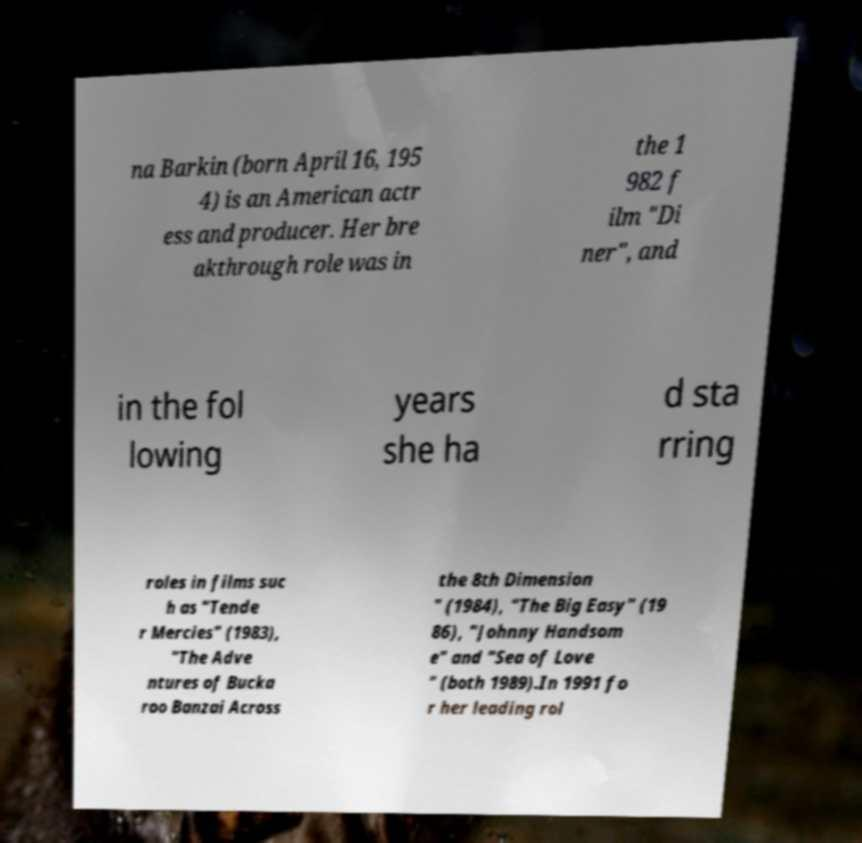Can you read and provide the text displayed in the image?This photo seems to have some interesting text. Can you extract and type it out for me? na Barkin (born April 16, 195 4) is an American actr ess and producer. Her bre akthrough role was in the 1 982 f ilm "Di ner", and in the fol lowing years she ha d sta rring roles in films suc h as "Tende r Mercies" (1983), "The Adve ntures of Bucka roo Banzai Across the 8th Dimension " (1984), "The Big Easy" (19 86), "Johnny Handsom e" and "Sea of Love " (both 1989).In 1991 fo r her leading rol 